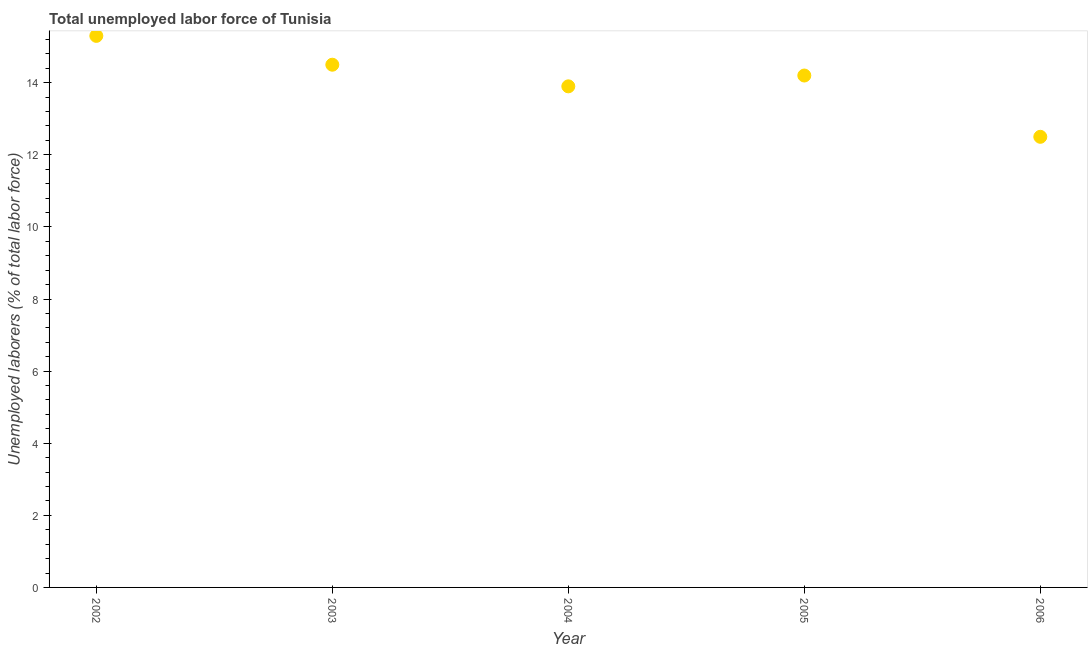What is the total unemployed labour force in 2004?
Your response must be concise. 13.9. Across all years, what is the maximum total unemployed labour force?
Provide a succinct answer. 15.3. In which year was the total unemployed labour force maximum?
Provide a succinct answer. 2002. In which year was the total unemployed labour force minimum?
Ensure brevity in your answer.  2006. What is the sum of the total unemployed labour force?
Keep it short and to the point. 70.4. What is the difference between the total unemployed labour force in 2003 and 2004?
Offer a very short reply. 0.6. What is the average total unemployed labour force per year?
Your response must be concise. 14.08. What is the median total unemployed labour force?
Keep it short and to the point. 14.2. In how many years, is the total unemployed labour force greater than 1.6 %?
Give a very brief answer. 5. What is the ratio of the total unemployed labour force in 2003 to that in 2006?
Offer a terse response. 1.16. What is the difference between the highest and the second highest total unemployed labour force?
Give a very brief answer. 0.8. What is the difference between the highest and the lowest total unemployed labour force?
Provide a succinct answer. 2.8. How many dotlines are there?
Offer a terse response. 1. How many years are there in the graph?
Your response must be concise. 5. Does the graph contain grids?
Provide a succinct answer. No. What is the title of the graph?
Keep it short and to the point. Total unemployed labor force of Tunisia. What is the label or title of the Y-axis?
Ensure brevity in your answer.  Unemployed laborers (% of total labor force). What is the Unemployed laborers (% of total labor force) in 2002?
Your answer should be compact. 15.3. What is the Unemployed laborers (% of total labor force) in 2003?
Provide a short and direct response. 14.5. What is the Unemployed laborers (% of total labor force) in 2004?
Provide a succinct answer. 13.9. What is the Unemployed laborers (% of total labor force) in 2005?
Offer a terse response. 14.2. What is the Unemployed laborers (% of total labor force) in 2006?
Provide a short and direct response. 12.5. What is the difference between the Unemployed laborers (% of total labor force) in 2002 and 2005?
Your response must be concise. 1.1. What is the difference between the Unemployed laborers (% of total labor force) in 2003 and 2004?
Keep it short and to the point. 0.6. What is the difference between the Unemployed laborers (% of total labor force) in 2003 and 2005?
Provide a succinct answer. 0.3. What is the difference between the Unemployed laborers (% of total labor force) in 2004 and 2006?
Your answer should be very brief. 1.4. What is the difference between the Unemployed laborers (% of total labor force) in 2005 and 2006?
Offer a very short reply. 1.7. What is the ratio of the Unemployed laborers (% of total labor force) in 2002 to that in 2003?
Your response must be concise. 1.05. What is the ratio of the Unemployed laborers (% of total labor force) in 2002 to that in 2004?
Offer a terse response. 1.1. What is the ratio of the Unemployed laborers (% of total labor force) in 2002 to that in 2005?
Your response must be concise. 1.08. What is the ratio of the Unemployed laborers (% of total labor force) in 2002 to that in 2006?
Provide a succinct answer. 1.22. What is the ratio of the Unemployed laborers (% of total labor force) in 2003 to that in 2004?
Make the answer very short. 1.04. What is the ratio of the Unemployed laborers (% of total labor force) in 2003 to that in 2005?
Your answer should be compact. 1.02. What is the ratio of the Unemployed laborers (% of total labor force) in 2003 to that in 2006?
Your answer should be very brief. 1.16. What is the ratio of the Unemployed laborers (% of total labor force) in 2004 to that in 2005?
Offer a very short reply. 0.98. What is the ratio of the Unemployed laborers (% of total labor force) in 2004 to that in 2006?
Keep it short and to the point. 1.11. What is the ratio of the Unemployed laborers (% of total labor force) in 2005 to that in 2006?
Ensure brevity in your answer.  1.14. 